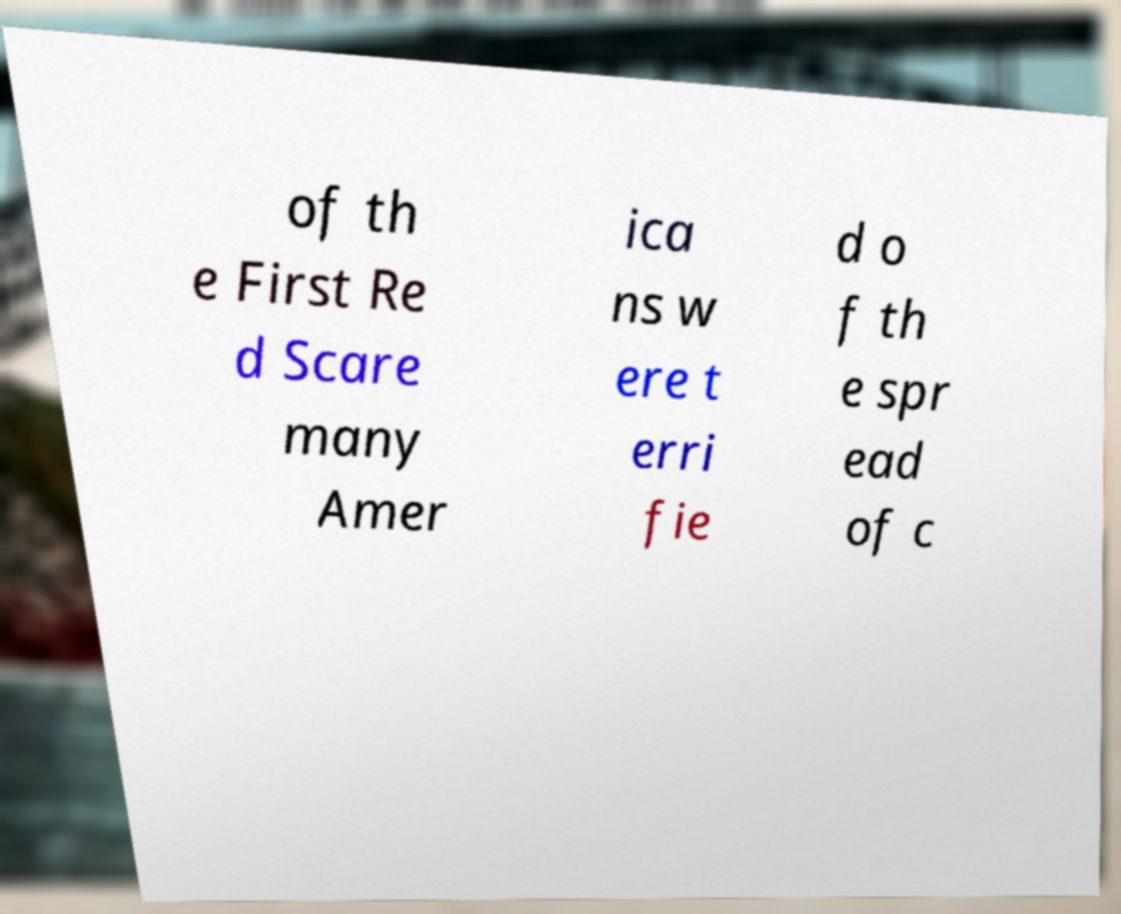There's text embedded in this image that I need extracted. Can you transcribe it verbatim? of th e First Re d Scare many Amer ica ns w ere t erri fie d o f th e spr ead of c 